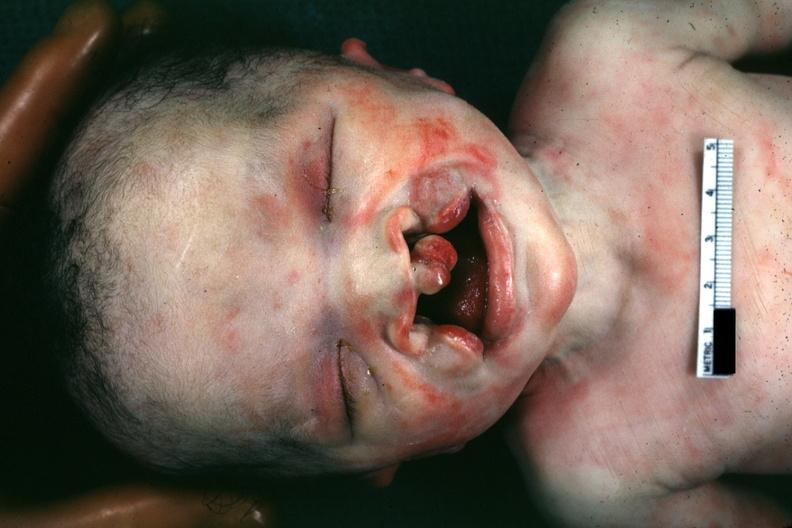s silver present?
Answer the question using a single word or phrase. No 